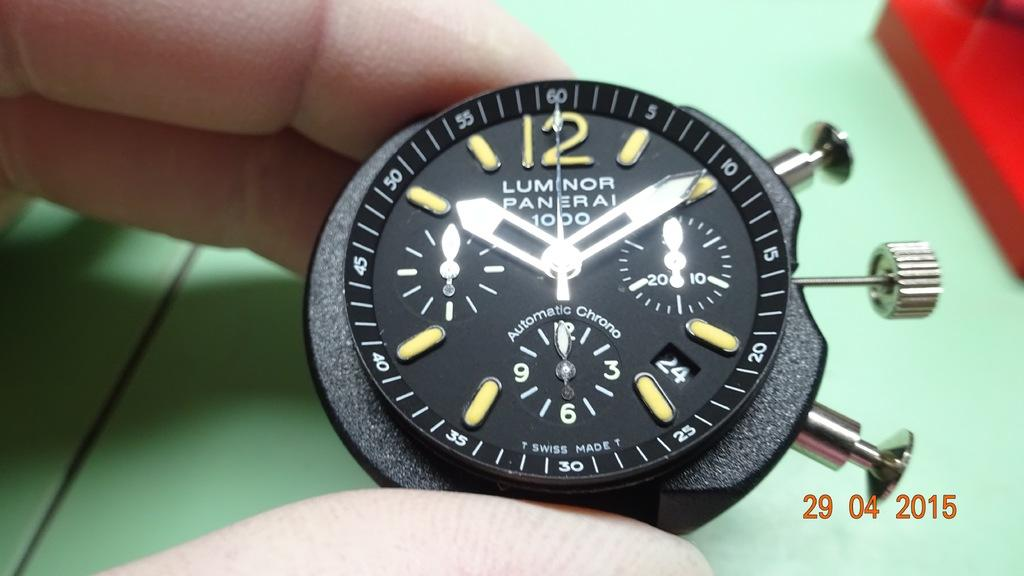<image>
Offer a succinct explanation of the picture presented. A Luminor watch face shows the time as 10:10. 